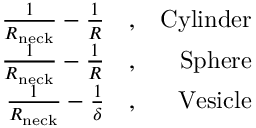Convert formula to latex. <formula><loc_0><loc_0><loc_500><loc_500>\begin{array} { r l r } { \frac { 1 } { R _ { n e c k } } - \frac { 1 } { R } } & , } & { C y l i n d e r } \\ { \frac { 1 } { R _ { n e c k } } - \frac { 1 } { R } } & , } & { S p h e r e } \\ { \frac { 1 } { R _ { n e c k } } - \frac { 1 } { \delta } } & , } & { V e s i c l e } \end{array}</formula> 